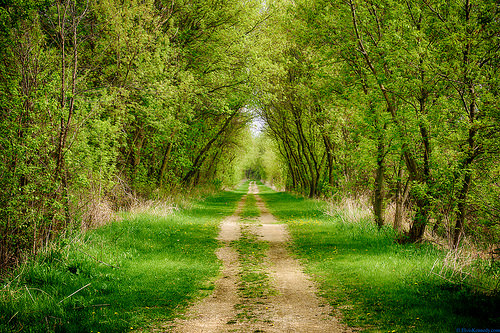<image>
Can you confirm if the dirt road is in front of the tree? No. The dirt road is not in front of the tree. The spatial positioning shows a different relationship between these objects. Is there a tree to the right of the road? Yes. From this viewpoint, the tree is positioned to the right side relative to the road. 